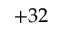<formula> <loc_0><loc_0><loc_500><loc_500>+ 3 2</formula> 